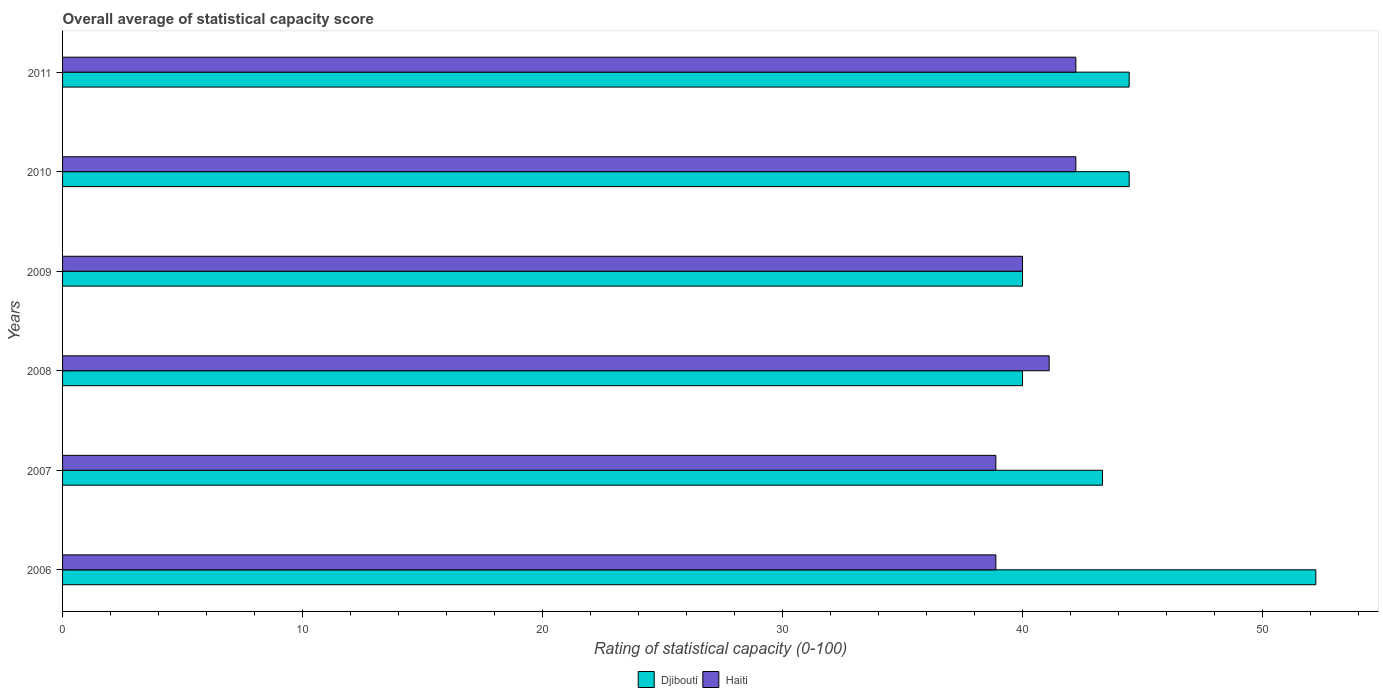How many groups of bars are there?
Keep it short and to the point. 6. Are the number of bars per tick equal to the number of legend labels?
Provide a succinct answer. Yes. Are the number of bars on each tick of the Y-axis equal?
Keep it short and to the point. Yes. What is the rating of statistical capacity in Djibouti in 2011?
Ensure brevity in your answer.  44.44. Across all years, what is the maximum rating of statistical capacity in Djibouti?
Make the answer very short. 52.22. Across all years, what is the minimum rating of statistical capacity in Haiti?
Keep it short and to the point. 38.89. What is the total rating of statistical capacity in Djibouti in the graph?
Your answer should be compact. 264.44. What is the difference between the rating of statistical capacity in Djibouti in 2006 and that in 2011?
Give a very brief answer. 7.78. What is the difference between the rating of statistical capacity in Haiti in 2010 and the rating of statistical capacity in Djibouti in 2007?
Ensure brevity in your answer.  -1.11. What is the average rating of statistical capacity in Haiti per year?
Provide a succinct answer. 40.56. In the year 2008, what is the difference between the rating of statistical capacity in Haiti and rating of statistical capacity in Djibouti?
Ensure brevity in your answer.  1.11. What is the ratio of the rating of statistical capacity in Haiti in 2009 to that in 2011?
Keep it short and to the point. 0.95. Is the difference between the rating of statistical capacity in Haiti in 2009 and 2011 greater than the difference between the rating of statistical capacity in Djibouti in 2009 and 2011?
Your answer should be compact. Yes. What is the difference between the highest and the second highest rating of statistical capacity in Djibouti?
Your response must be concise. 7.78. What is the difference between the highest and the lowest rating of statistical capacity in Djibouti?
Provide a short and direct response. 12.22. In how many years, is the rating of statistical capacity in Haiti greater than the average rating of statistical capacity in Haiti taken over all years?
Provide a succinct answer. 3. Is the sum of the rating of statistical capacity in Djibouti in 2007 and 2010 greater than the maximum rating of statistical capacity in Haiti across all years?
Your response must be concise. Yes. What does the 1st bar from the top in 2009 represents?
Give a very brief answer. Haiti. What does the 1st bar from the bottom in 2010 represents?
Your answer should be compact. Djibouti. How many bars are there?
Offer a very short reply. 12. What is the difference between two consecutive major ticks on the X-axis?
Ensure brevity in your answer.  10. Does the graph contain grids?
Ensure brevity in your answer.  No. Where does the legend appear in the graph?
Make the answer very short. Bottom center. How many legend labels are there?
Make the answer very short. 2. What is the title of the graph?
Offer a terse response. Overall average of statistical capacity score. Does "Belgium" appear as one of the legend labels in the graph?
Keep it short and to the point. No. What is the label or title of the X-axis?
Your answer should be very brief. Rating of statistical capacity (0-100). What is the label or title of the Y-axis?
Your response must be concise. Years. What is the Rating of statistical capacity (0-100) of Djibouti in 2006?
Ensure brevity in your answer.  52.22. What is the Rating of statistical capacity (0-100) in Haiti in 2006?
Offer a terse response. 38.89. What is the Rating of statistical capacity (0-100) in Djibouti in 2007?
Provide a succinct answer. 43.33. What is the Rating of statistical capacity (0-100) in Haiti in 2007?
Your answer should be compact. 38.89. What is the Rating of statistical capacity (0-100) of Djibouti in 2008?
Your answer should be very brief. 40. What is the Rating of statistical capacity (0-100) in Haiti in 2008?
Your answer should be very brief. 41.11. What is the Rating of statistical capacity (0-100) in Djibouti in 2009?
Make the answer very short. 40. What is the Rating of statistical capacity (0-100) in Djibouti in 2010?
Your answer should be very brief. 44.44. What is the Rating of statistical capacity (0-100) of Haiti in 2010?
Provide a succinct answer. 42.22. What is the Rating of statistical capacity (0-100) of Djibouti in 2011?
Provide a short and direct response. 44.44. What is the Rating of statistical capacity (0-100) in Haiti in 2011?
Ensure brevity in your answer.  42.22. Across all years, what is the maximum Rating of statistical capacity (0-100) of Djibouti?
Keep it short and to the point. 52.22. Across all years, what is the maximum Rating of statistical capacity (0-100) in Haiti?
Your answer should be compact. 42.22. Across all years, what is the minimum Rating of statistical capacity (0-100) of Haiti?
Your answer should be very brief. 38.89. What is the total Rating of statistical capacity (0-100) of Djibouti in the graph?
Your answer should be very brief. 264.44. What is the total Rating of statistical capacity (0-100) in Haiti in the graph?
Make the answer very short. 243.33. What is the difference between the Rating of statistical capacity (0-100) in Djibouti in 2006 and that in 2007?
Your answer should be very brief. 8.89. What is the difference between the Rating of statistical capacity (0-100) in Haiti in 2006 and that in 2007?
Your response must be concise. 0. What is the difference between the Rating of statistical capacity (0-100) of Djibouti in 2006 and that in 2008?
Your answer should be compact. 12.22. What is the difference between the Rating of statistical capacity (0-100) of Haiti in 2006 and that in 2008?
Your answer should be very brief. -2.22. What is the difference between the Rating of statistical capacity (0-100) of Djibouti in 2006 and that in 2009?
Your answer should be very brief. 12.22. What is the difference between the Rating of statistical capacity (0-100) of Haiti in 2006 and that in 2009?
Provide a short and direct response. -1.11. What is the difference between the Rating of statistical capacity (0-100) of Djibouti in 2006 and that in 2010?
Your response must be concise. 7.78. What is the difference between the Rating of statistical capacity (0-100) of Djibouti in 2006 and that in 2011?
Keep it short and to the point. 7.78. What is the difference between the Rating of statistical capacity (0-100) in Haiti in 2007 and that in 2008?
Your answer should be very brief. -2.22. What is the difference between the Rating of statistical capacity (0-100) of Haiti in 2007 and that in 2009?
Provide a short and direct response. -1.11. What is the difference between the Rating of statistical capacity (0-100) of Djibouti in 2007 and that in 2010?
Your answer should be compact. -1.11. What is the difference between the Rating of statistical capacity (0-100) in Haiti in 2007 and that in 2010?
Provide a short and direct response. -3.33. What is the difference between the Rating of statistical capacity (0-100) in Djibouti in 2007 and that in 2011?
Your answer should be compact. -1.11. What is the difference between the Rating of statistical capacity (0-100) of Djibouti in 2008 and that in 2010?
Provide a short and direct response. -4.44. What is the difference between the Rating of statistical capacity (0-100) of Haiti in 2008 and that in 2010?
Keep it short and to the point. -1.11. What is the difference between the Rating of statistical capacity (0-100) of Djibouti in 2008 and that in 2011?
Your answer should be very brief. -4.44. What is the difference between the Rating of statistical capacity (0-100) in Haiti in 2008 and that in 2011?
Provide a succinct answer. -1.11. What is the difference between the Rating of statistical capacity (0-100) in Djibouti in 2009 and that in 2010?
Ensure brevity in your answer.  -4.44. What is the difference between the Rating of statistical capacity (0-100) in Haiti in 2009 and that in 2010?
Make the answer very short. -2.22. What is the difference between the Rating of statistical capacity (0-100) of Djibouti in 2009 and that in 2011?
Your answer should be very brief. -4.44. What is the difference between the Rating of statistical capacity (0-100) in Haiti in 2009 and that in 2011?
Ensure brevity in your answer.  -2.22. What is the difference between the Rating of statistical capacity (0-100) in Djibouti in 2010 and that in 2011?
Ensure brevity in your answer.  0. What is the difference between the Rating of statistical capacity (0-100) in Haiti in 2010 and that in 2011?
Your response must be concise. 0. What is the difference between the Rating of statistical capacity (0-100) of Djibouti in 2006 and the Rating of statistical capacity (0-100) of Haiti in 2007?
Give a very brief answer. 13.33. What is the difference between the Rating of statistical capacity (0-100) of Djibouti in 2006 and the Rating of statistical capacity (0-100) of Haiti in 2008?
Provide a succinct answer. 11.11. What is the difference between the Rating of statistical capacity (0-100) in Djibouti in 2006 and the Rating of statistical capacity (0-100) in Haiti in 2009?
Ensure brevity in your answer.  12.22. What is the difference between the Rating of statistical capacity (0-100) in Djibouti in 2006 and the Rating of statistical capacity (0-100) in Haiti in 2011?
Make the answer very short. 10. What is the difference between the Rating of statistical capacity (0-100) in Djibouti in 2007 and the Rating of statistical capacity (0-100) in Haiti in 2008?
Give a very brief answer. 2.22. What is the difference between the Rating of statistical capacity (0-100) in Djibouti in 2007 and the Rating of statistical capacity (0-100) in Haiti in 2009?
Keep it short and to the point. 3.33. What is the difference between the Rating of statistical capacity (0-100) in Djibouti in 2007 and the Rating of statistical capacity (0-100) in Haiti in 2011?
Your response must be concise. 1.11. What is the difference between the Rating of statistical capacity (0-100) of Djibouti in 2008 and the Rating of statistical capacity (0-100) of Haiti in 2010?
Offer a terse response. -2.22. What is the difference between the Rating of statistical capacity (0-100) of Djibouti in 2008 and the Rating of statistical capacity (0-100) of Haiti in 2011?
Make the answer very short. -2.22. What is the difference between the Rating of statistical capacity (0-100) in Djibouti in 2009 and the Rating of statistical capacity (0-100) in Haiti in 2010?
Provide a short and direct response. -2.22. What is the difference between the Rating of statistical capacity (0-100) of Djibouti in 2009 and the Rating of statistical capacity (0-100) of Haiti in 2011?
Give a very brief answer. -2.22. What is the difference between the Rating of statistical capacity (0-100) of Djibouti in 2010 and the Rating of statistical capacity (0-100) of Haiti in 2011?
Give a very brief answer. 2.22. What is the average Rating of statistical capacity (0-100) of Djibouti per year?
Offer a very short reply. 44.07. What is the average Rating of statistical capacity (0-100) of Haiti per year?
Your answer should be very brief. 40.56. In the year 2006, what is the difference between the Rating of statistical capacity (0-100) in Djibouti and Rating of statistical capacity (0-100) in Haiti?
Make the answer very short. 13.33. In the year 2007, what is the difference between the Rating of statistical capacity (0-100) of Djibouti and Rating of statistical capacity (0-100) of Haiti?
Make the answer very short. 4.44. In the year 2008, what is the difference between the Rating of statistical capacity (0-100) in Djibouti and Rating of statistical capacity (0-100) in Haiti?
Provide a short and direct response. -1.11. In the year 2009, what is the difference between the Rating of statistical capacity (0-100) of Djibouti and Rating of statistical capacity (0-100) of Haiti?
Offer a very short reply. 0. In the year 2010, what is the difference between the Rating of statistical capacity (0-100) of Djibouti and Rating of statistical capacity (0-100) of Haiti?
Your answer should be compact. 2.22. In the year 2011, what is the difference between the Rating of statistical capacity (0-100) of Djibouti and Rating of statistical capacity (0-100) of Haiti?
Offer a very short reply. 2.22. What is the ratio of the Rating of statistical capacity (0-100) of Djibouti in 2006 to that in 2007?
Your answer should be compact. 1.21. What is the ratio of the Rating of statistical capacity (0-100) in Haiti in 2006 to that in 2007?
Your answer should be compact. 1. What is the ratio of the Rating of statistical capacity (0-100) of Djibouti in 2006 to that in 2008?
Your response must be concise. 1.31. What is the ratio of the Rating of statistical capacity (0-100) of Haiti in 2006 to that in 2008?
Give a very brief answer. 0.95. What is the ratio of the Rating of statistical capacity (0-100) in Djibouti in 2006 to that in 2009?
Your response must be concise. 1.31. What is the ratio of the Rating of statistical capacity (0-100) in Haiti in 2006 to that in 2009?
Make the answer very short. 0.97. What is the ratio of the Rating of statistical capacity (0-100) in Djibouti in 2006 to that in 2010?
Ensure brevity in your answer.  1.18. What is the ratio of the Rating of statistical capacity (0-100) in Haiti in 2006 to that in 2010?
Your response must be concise. 0.92. What is the ratio of the Rating of statistical capacity (0-100) in Djibouti in 2006 to that in 2011?
Give a very brief answer. 1.18. What is the ratio of the Rating of statistical capacity (0-100) of Haiti in 2006 to that in 2011?
Make the answer very short. 0.92. What is the ratio of the Rating of statistical capacity (0-100) in Haiti in 2007 to that in 2008?
Keep it short and to the point. 0.95. What is the ratio of the Rating of statistical capacity (0-100) of Djibouti in 2007 to that in 2009?
Provide a succinct answer. 1.08. What is the ratio of the Rating of statistical capacity (0-100) in Haiti in 2007 to that in 2009?
Make the answer very short. 0.97. What is the ratio of the Rating of statistical capacity (0-100) in Haiti in 2007 to that in 2010?
Give a very brief answer. 0.92. What is the ratio of the Rating of statistical capacity (0-100) of Djibouti in 2007 to that in 2011?
Give a very brief answer. 0.97. What is the ratio of the Rating of statistical capacity (0-100) of Haiti in 2007 to that in 2011?
Your answer should be compact. 0.92. What is the ratio of the Rating of statistical capacity (0-100) in Haiti in 2008 to that in 2009?
Ensure brevity in your answer.  1.03. What is the ratio of the Rating of statistical capacity (0-100) in Haiti in 2008 to that in 2010?
Provide a short and direct response. 0.97. What is the ratio of the Rating of statistical capacity (0-100) in Djibouti in 2008 to that in 2011?
Keep it short and to the point. 0.9. What is the ratio of the Rating of statistical capacity (0-100) of Haiti in 2008 to that in 2011?
Make the answer very short. 0.97. What is the ratio of the Rating of statistical capacity (0-100) of Haiti in 2009 to that in 2010?
Your answer should be very brief. 0.95. What is the ratio of the Rating of statistical capacity (0-100) of Djibouti in 2009 to that in 2011?
Provide a succinct answer. 0.9. What is the ratio of the Rating of statistical capacity (0-100) in Haiti in 2010 to that in 2011?
Offer a very short reply. 1. What is the difference between the highest and the second highest Rating of statistical capacity (0-100) in Djibouti?
Your answer should be compact. 7.78. What is the difference between the highest and the lowest Rating of statistical capacity (0-100) of Djibouti?
Ensure brevity in your answer.  12.22. What is the difference between the highest and the lowest Rating of statistical capacity (0-100) in Haiti?
Offer a very short reply. 3.33. 